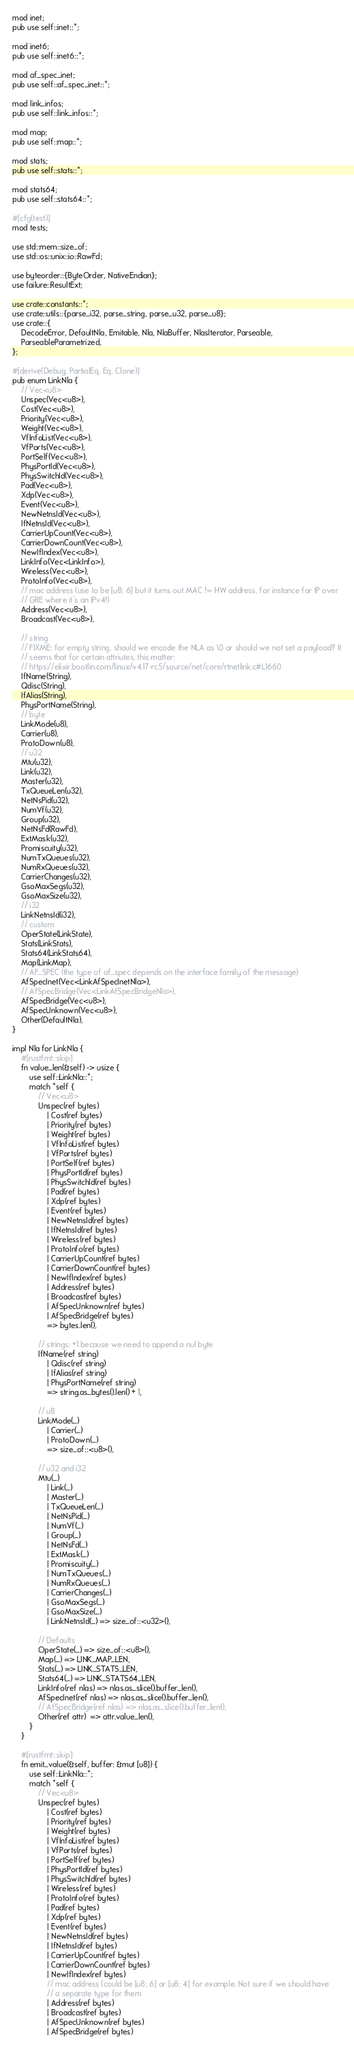Convert code to text. <code><loc_0><loc_0><loc_500><loc_500><_Rust_>mod inet;
pub use self::inet::*;

mod inet6;
pub use self::inet6::*;

mod af_spec_inet;
pub use self::af_spec_inet::*;

mod link_infos;
pub use self::link_infos::*;

mod map;
pub use self::map::*;

mod stats;
pub use self::stats::*;

mod stats64;
pub use self::stats64::*;

#[cfg(test)]
mod tests;

use std::mem::size_of;
use std::os::unix::io::RawFd;

use byteorder::{ByteOrder, NativeEndian};
use failure::ResultExt;

use crate::constants::*;
use crate::utils::{parse_i32, parse_string, parse_u32, parse_u8};
use crate::{
    DecodeError, DefaultNla, Emitable, Nla, NlaBuffer, NlasIterator, Parseable,
    ParseableParametrized,
};

#[derive(Debug, PartialEq, Eq, Clone)]
pub enum LinkNla {
    // Vec<u8>
    Unspec(Vec<u8>),
    Cost(Vec<u8>),
    Priority(Vec<u8>),
    Weight(Vec<u8>),
    VfInfoList(Vec<u8>),
    VfPorts(Vec<u8>),
    PortSelf(Vec<u8>),
    PhysPortId(Vec<u8>),
    PhysSwitchId(Vec<u8>),
    Pad(Vec<u8>),
    Xdp(Vec<u8>),
    Event(Vec<u8>),
    NewNetnsId(Vec<u8>),
    IfNetnsId(Vec<u8>),
    CarrierUpCount(Vec<u8>),
    CarrierDownCount(Vec<u8>),
    NewIfIndex(Vec<u8>),
    LinkInfo(Vec<LinkInfo>),
    Wireless(Vec<u8>),
    ProtoInfo(Vec<u8>),
    // mac address (use to be [u8; 6] but it turns out MAC != HW address, for instance for IP over
    // GRE where it's an IPv4!)
    Address(Vec<u8>),
    Broadcast(Vec<u8>),

    // string
    // FIXME: for empty string, should we encode the NLA as \0 or should we not set a payload? It
    // seems that for certain attriutes, this matter:
    // https://elixir.bootlin.com/linux/v4.17-rc5/source/net/core/rtnetlink.c#L1660
    IfName(String),
    Qdisc(String),
    IfAlias(String),
    PhysPortName(String),
    // byte
    LinkMode(u8),
    Carrier(u8),
    ProtoDown(u8),
    // u32
    Mtu(u32),
    Link(u32),
    Master(u32),
    TxQueueLen(u32),
    NetNsPid(u32),
    NumVf(u32),
    Group(u32),
    NetNsFd(RawFd),
    ExtMask(u32),
    Promiscuity(u32),
    NumTxQueues(u32),
    NumRxQueues(u32),
    CarrierChanges(u32),
    GsoMaxSegs(u32),
    GsoMaxSize(u32),
    // i32
    LinkNetnsId(i32),
    // custom
    OperState(LinkState),
    Stats(LinkStats),
    Stats64(LinkStats64),
    Map(LinkMap),
    // AF_SPEC (the type of af_spec depends on the interface family of the message)
    AfSpecInet(Vec<LinkAfSpecInetNla>),
    // AfSpecBridge(Vec<LinkAfSpecBridgeNla>),
    AfSpecBridge(Vec<u8>),
    AfSpecUnknown(Vec<u8>),
    Other(DefaultNla),
}

impl Nla for LinkNla {
    #[rustfmt::skip]
    fn value_len(&self) -> usize {
        use self::LinkNla::*;
        match *self {
            // Vec<u8>
            Unspec(ref bytes)
                | Cost(ref bytes)
                | Priority(ref bytes)
                | Weight(ref bytes)
                | VfInfoList(ref bytes)
                | VfPorts(ref bytes)
                | PortSelf(ref bytes)
                | PhysPortId(ref bytes)
                | PhysSwitchId(ref bytes)
                | Pad(ref bytes)
                | Xdp(ref bytes)
                | Event(ref bytes)
                | NewNetnsId(ref bytes)
                | IfNetnsId(ref bytes)
                | Wireless(ref bytes)
                | ProtoInfo(ref bytes)
                | CarrierUpCount(ref bytes)
                | CarrierDownCount(ref bytes)
                | NewIfIndex(ref bytes)
                | Address(ref bytes)
                | Broadcast(ref bytes)
                | AfSpecUnknown(ref bytes)
                | AfSpecBridge(ref bytes)
                => bytes.len(),

            // strings: +1 because we need to append a nul byte
            IfName(ref string)
                | Qdisc(ref string)
                | IfAlias(ref string)
                | PhysPortName(ref string)
                => string.as_bytes().len() + 1,

            // u8
            LinkMode(_)
                | Carrier(_)
                | ProtoDown(_)
                => size_of::<u8>(),

            // u32 and i32
            Mtu(_)
                | Link(_)
                | Master(_)
                | TxQueueLen(_)
                | NetNsPid(_)
                | NumVf(_)
                | Group(_)
                | NetNsFd(_)
                | ExtMask(_)
                | Promiscuity(_)
                | NumTxQueues(_)
                | NumRxQueues(_)
                | CarrierChanges(_)
                | GsoMaxSegs(_)
                | GsoMaxSize(_)
                | LinkNetnsId(_) => size_of::<u32>(),

            // Defaults
            OperState(_) => size_of::<u8>(),
            Map(_) => LINK_MAP_LEN,
            Stats(_) => LINK_STATS_LEN,
            Stats64(_) => LINK_STATS64_LEN,
            LinkInfo(ref nlas) => nlas.as_slice().buffer_len(),
            AfSpecInet(ref nlas) => nlas.as_slice().buffer_len(),
            // AfSpecBridge(ref nlas) => nlas.as_slice().buffer_len(),
            Other(ref attr)  => attr.value_len(),
        }
    }

    #[rustfmt::skip]
    fn emit_value(&self, buffer: &mut [u8]) {
        use self::LinkNla::*;
        match *self {
            // Vec<u8>
            Unspec(ref bytes)
                | Cost(ref bytes)
                | Priority(ref bytes)
                | Weight(ref bytes)
                | VfInfoList(ref bytes)
                | VfPorts(ref bytes)
                | PortSelf(ref bytes)
                | PhysPortId(ref bytes)
                | PhysSwitchId(ref bytes)
                | Wireless(ref bytes)
                | ProtoInfo(ref bytes)
                | Pad(ref bytes)
                | Xdp(ref bytes)
                | Event(ref bytes)
                | NewNetnsId(ref bytes)
                | IfNetnsId(ref bytes)
                | CarrierUpCount(ref bytes)
                | CarrierDownCount(ref bytes)
                | NewIfIndex(ref bytes)
                // mac address (could be [u8; 6] or [u8; 4] for example. Not sure if we should have
                // a separate type for them
                | Address(ref bytes)
                | Broadcast(ref bytes)
                | AfSpecUnknown(ref bytes)
                | AfSpecBridge(ref bytes)</code> 